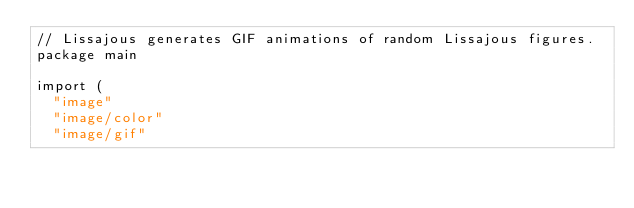<code> <loc_0><loc_0><loc_500><loc_500><_Go_>// Lissajous generates GIF animations of random Lissajous figures.
package main

import (
	"image"
	"image/color"
	"image/gif"</code> 